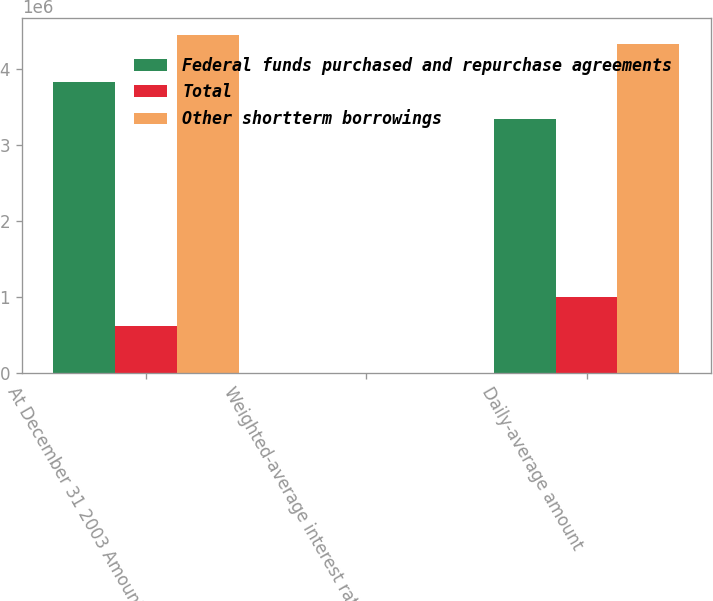Convert chart. <chart><loc_0><loc_0><loc_500><loc_500><stacked_bar_chart><ecel><fcel>At December 31 2003 Amount<fcel>Weighted-average interest rate<fcel>Daily-average amount<nl><fcel>Federal funds purchased and repurchase agreements<fcel>3.83218e+06<fcel>0.92<fcel>3.33758e+06<nl><fcel>Total<fcel>610064<fcel>1.25<fcel>993235<nl><fcel>Other shortterm borrowings<fcel>4.44225e+06<fcel>0.96<fcel>4.33082e+06<nl></chart> 